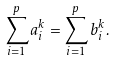<formula> <loc_0><loc_0><loc_500><loc_500>\sum _ { i = 1 } ^ { p } a _ { i } ^ { k } = \sum _ { i = 1 } ^ { p } b _ { i } ^ { k } .</formula> 